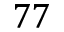Convert formula to latex. <formula><loc_0><loc_0><loc_500><loc_500>7 7</formula> 